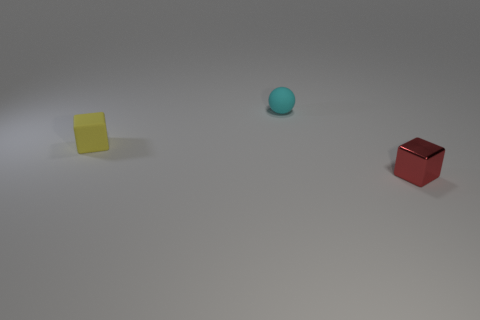Add 2 rubber objects. How many objects exist? 5 Subtract all yellow blocks. How many blocks are left? 1 Subtract all spheres. How many objects are left? 2 Add 1 metal objects. How many metal objects are left? 2 Add 2 blue metallic cylinders. How many blue metallic cylinders exist? 2 Subtract 0 red cylinders. How many objects are left? 3 Subtract 1 balls. How many balls are left? 0 Subtract all red balls. Subtract all brown cylinders. How many balls are left? 1 Subtract all small metal blocks. Subtract all small yellow cubes. How many objects are left? 1 